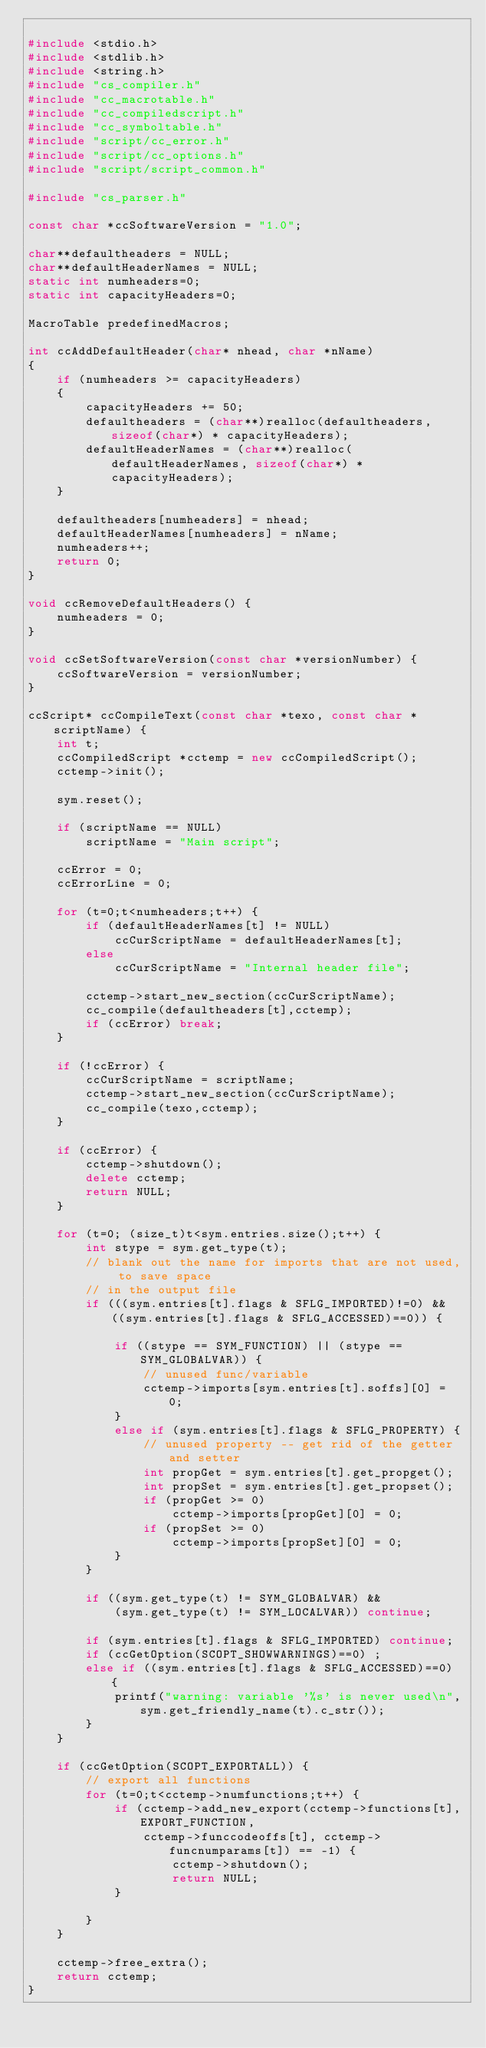<code> <loc_0><loc_0><loc_500><loc_500><_C++_>
#include <stdio.h>
#include <stdlib.h>
#include <string.h>
#include "cs_compiler.h"
#include "cc_macrotable.h"
#include "cc_compiledscript.h"
#include "cc_symboltable.h"
#include "script/cc_error.h"
#include "script/cc_options.h"
#include "script/script_common.h"

#include "cs_parser.h"

const char *ccSoftwareVersion = "1.0";

char**defaultheaders = NULL;
char**defaultHeaderNames = NULL;
static int numheaders=0;
static int capacityHeaders=0;

MacroTable predefinedMacros;

int ccAddDefaultHeader(char* nhead, char *nName)
{
    if (numheaders >= capacityHeaders)
    {
        capacityHeaders += 50;
        defaultheaders = (char**)realloc(defaultheaders, sizeof(char*) * capacityHeaders);
        defaultHeaderNames = (char**)realloc(defaultHeaderNames, sizeof(char*) * capacityHeaders);
    }

    defaultheaders[numheaders] = nhead;
    defaultHeaderNames[numheaders] = nName;
    numheaders++;
    return 0;
}

void ccRemoveDefaultHeaders() {
    numheaders = 0;
}

void ccSetSoftwareVersion(const char *versionNumber) {
    ccSoftwareVersion = versionNumber;
}

ccScript* ccCompileText(const char *texo, const char *scriptName) {
    int t;
    ccCompiledScript *cctemp = new ccCompiledScript();
    cctemp->init();

    sym.reset();

    if (scriptName == NULL)
        scriptName = "Main script";

    ccError = 0;
    ccErrorLine = 0;

    for (t=0;t<numheaders;t++) {
        if (defaultHeaderNames[t] != NULL)
            ccCurScriptName = defaultHeaderNames[t];
        else
            ccCurScriptName = "Internal header file";

        cctemp->start_new_section(ccCurScriptName);
        cc_compile(defaultheaders[t],cctemp);
        if (ccError) break;
    }

    if (!ccError) {
        ccCurScriptName = scriptName;
        cctemp->start_new_section(ccCurScriptName);
        cc_compile(texo,cctemp);
    }

    if (ccError) {
        cctemp->shutdown();
        delete cctemp;
        return NULL;
    }

    for (t=0; (size_t)t<sym.entries.size();t++) {
        int stype = sym.get_type(t);
        // blank out the name for imports that are not used, to save space
        // in the output file
        if (((sym.entries[t].flags & SFLG_IMPORTED)!=0) && ((sym.entries[t].flags & SFLG_ACCESSED)==0)) {

            if ((stype == SYM_FUNCTION) || (stype == SYM_GLOBALVAR)) {
                // unused func/variable
                cctemp->imports[sym.entries[t].soffs][0] = 0;
            }
            else if (sym.entries[t].flags & SFLG_PROPERTY) {
                // unused property -- get rid of the getter and setter
                int propGet = sym.entries[t].get_propget();
                int propSet = sym.entries[t].get_propset();
                if (propGet >= 0)
                    cctemp->imports[propGet][0] = 0;
                if (propSet >= 0)
                    cctemp->imports[propSet][0] = 0;
            }
        }

        if ((sym.get_type(t) != SYM_GLOBALVAR) &&
            (sym.get_type(t) != SYM_LOCALVAR)) continue;

        if (sym.entries[t].flags & SFLG_IMPORTED) continue;
        if (ccGetOption(SCOPT_SHOWWARNINGS)==0) ;
        else if ((sym.entries[t].flags & SFLG_ACCESSED)==0) {
            printf("warning: variable '%s' is never used\n",sym.get_friendly_name(t).c_str());
        }
    }

    if (ccGetOption(SCOPT_EXPORTALL)) {
        // export all functions
        for (t=0;t<cctemp->numfunctions;t++) {
            if (cctemp->add_new_export(cctemp->functions[t],EXPORT_FUNCTION,
                cctemp->funccodeoffs[t], cctemp->funcnumparams[t]) == -1) {
                    cctemp->shutdown();
                    return NULL;
            }

        }
    }

    cctemp->free_extra();
    return cctemp;
}
</code> 